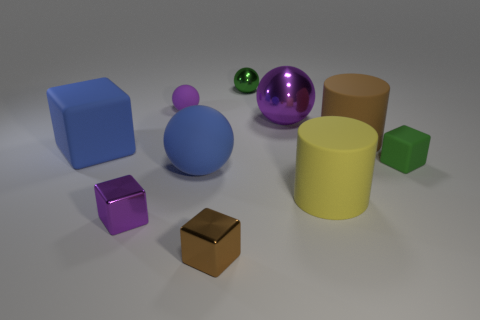Subtract 1 balls. How many balls are left? 3 Subtract all blue balls. How many balls are left? 3 Subtract all cyan balls. Subtract all blue cubes. How many balls are left? 4 Subtract all cylinders. How many objects are left? 8 Add 6 purple metallic blocks. How many purple metallic blocks are left? 7 Add 2 green balls. How many green balls exist? 3 Subtract 0 gray blocks. How many objects are left? 10 Subtract all brown metallic blocks. Subtract all small brown metal things. How many objects are left? 8 